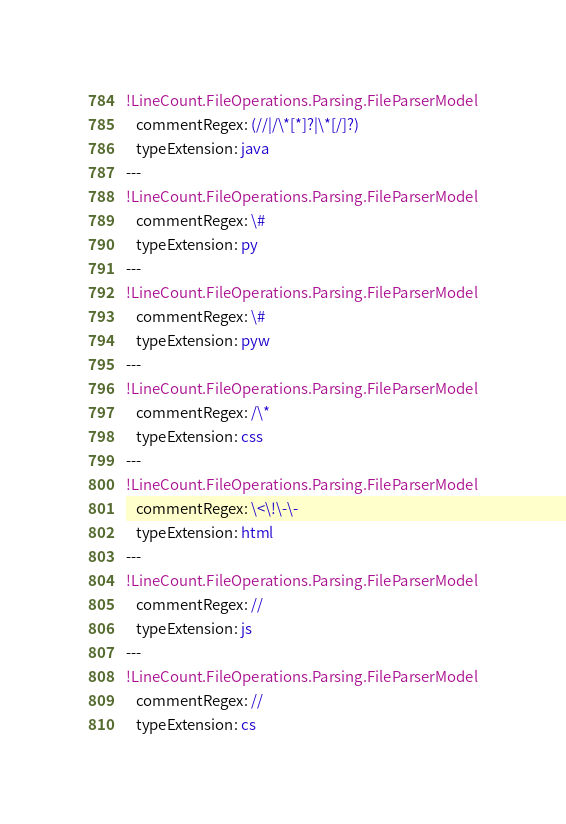<code> <loc_0><loc_0><loc_500><loc_500><_YAML_>!LineCount.FileOperations.Parsing.FileParserModel
   commentRegex: (//|/\*[*]?|\*[/]?)
   typeExtension: java
---
!LineCount.FileOperations.Parsing.FileParserModel
   commentRegex: \#
   typeExtension: py
---
!LineCount.FileOperations.Parsing.FileParserModel
   commentRegex: \#
   typeExtension: pyw
---
!LineCount.FileOperations.Parsing.FileParserModel
   commentRegex: /\*
   typeExtension: css
---
!LineCount.FileOperations.Parsing.FileParserModel
   commentRegex: \<\!\-\-
   typeExtension: html
---
!LineCount.FileOperations.Parsing.FileParserModel
   commentRegex: //
   typeExtension: js
---
!LineCount.FileOperations.Parsing.FileParserModel
   commentRegex: //
   typeExtension: cs
</code> 